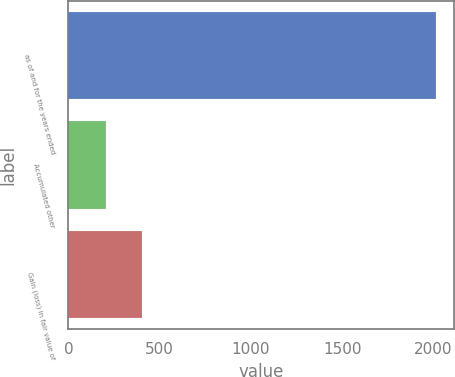<chart> <loc_0><loc_0><loc_500><loc_500><bar_chart><fcel>as of and for the years ended<fcel>Accumulated other<fcel>Gain (loss) in fair value of<nl><fcel>2012<fcel>203<fcel>404<nl></chart> 